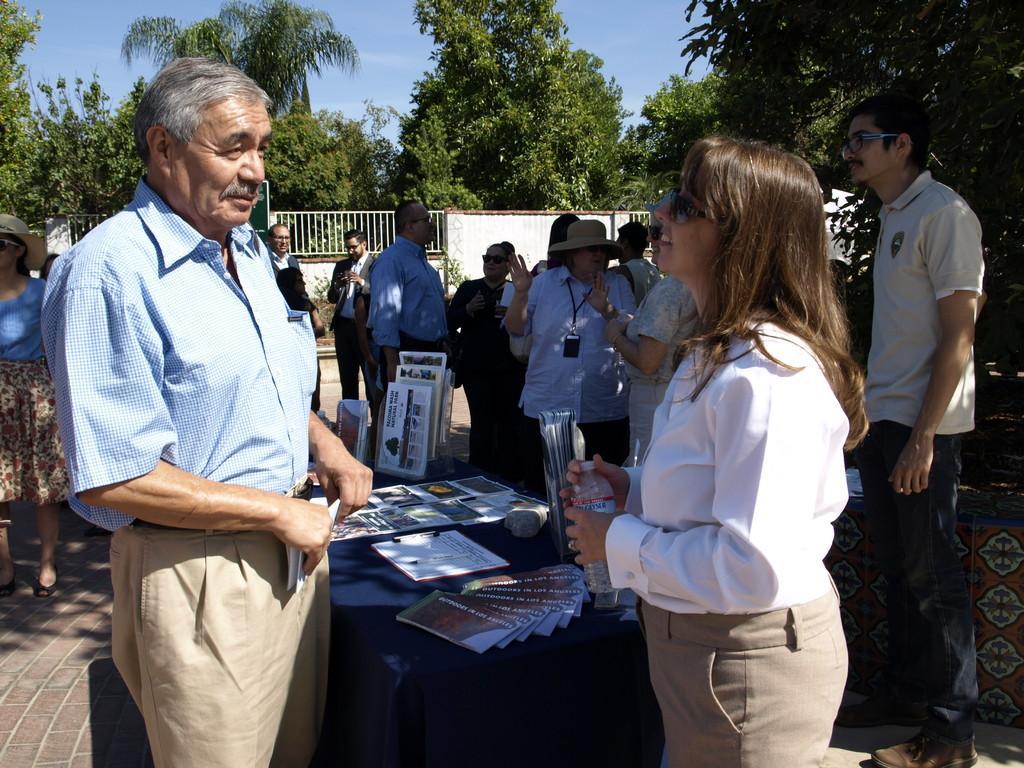Describe this image in one or two sentences. In the image I can see people are standing among them some are holding objects in hands. The woman in front of the image is holding a bottle in hands and the man on the left side is holding an object in hands. In the background I can see fence, trees, a table which has some objects on it and the sky. 